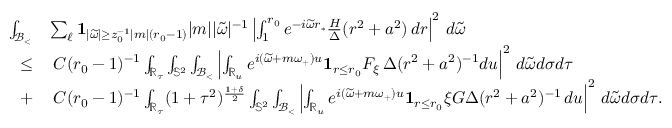Convert formula to latex. <formula><loc_0><loc_0><loc_500><loc_500>\begin{array} { r l } { \int _ { { \mathcal { B } _ { < } } } } & { \sum _ { \ell } 1 _ { | \widetilde { \omega } | \geq z _ { 0 } ^ { - 1 } | m | ( r _ { 0 } - 1 ) } | m | | \widetilde { \omega } | ^ { - 1 } \left | \int _ { 1 } ^ { r _ { 0 } } e ^ { - i \widetilde { \omega } r _ { * } } \frac { H } { \Delta } ( r ^ { 2 } + a ^ { 2 } ) \, d r \right | ^ { 2 } \, d \widetilde { \omega } } \\ { \leq } & { \, C ( r _ { 0 } - 1 ) ^ { - 1 } \int _ { \mathbb { R } _ { \tau } } \int _ { \mathbb { S } ^ { 2 } } \int _ { { \mathcal { B } _ { < } } } \left | \int _ { \mathbb { R } _ { u } } e ^ { i ( \widetilde { \omega } + m \omega _ { + } ) u } 1 _ { r \leq r _ { 0 } } F _ { \xi } \, \Delta ( r ^ { 2 } + a ^ { 2 } ) ^ { - 1 } d u \right | ^ { 2 } \, d \widetilde { \omega } d \sigma d \tau } \\ { + } & { \, C ( r _ { 0 } - 1 ) ^ { - 1 } \int _ { \mathbb { R } _ { \tau } } ( 1 + \tau ^ { 2 } ) ^ { \frac { 1 + \delta } { 2 } } \int _ { \mathbb { S } ^ { 2 } } \int _ { { \mathcal { B } _ { < } } } \left | \int _ { \mathbb { R } _ { u } } e ^ { i ( \widetilde { \omega } + m \omega _ { + } ) u } 1 _ { r \leq r _ { 0 } } \xi G \Delta ( r ^ { 2 } + a ^ { 2 } ) ^ { - 1 } \, d u \right | ^ { 2 } \, d \widetilde { \omega } d \sigma d \tau . } \end{array}</formula> 